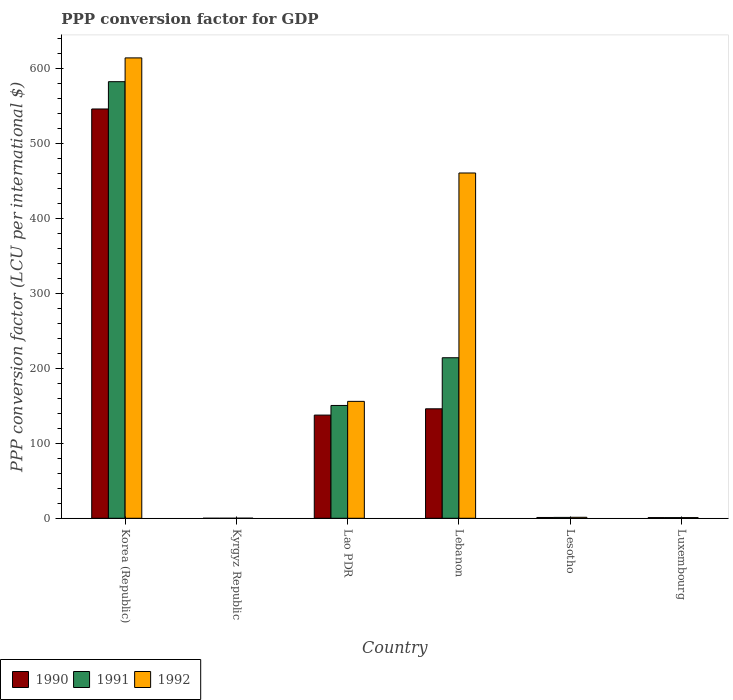How many different coloured bars are there?
Offer a terse response. 3. How many bars are there on the 4th tick from the left?
Ensure brevity in your answer.  3. In how many cases, is the number of bars for a given country not equal to the number of legend labels?
Ensure brevity in your answer.  0. What is the PPP conversion factor for GDP in 1990 in Lao PDR?
Provide a short and direct response. 137.64. Across all countries, what is the maximum PPP conversion factor for GDP in 1992?
Offer a very short reply. 614.12. Across all countries, what is the minimum PPP conversion factor for GDP in 1992?
Keep it short and to the point. 0.09. In which country was the PPP conversion factor for GDP in 1991 minimum?
Your response must be concise. Kyrgyz Republic. What is the total PPP conversion factor for GDP in 1991 in the graph?
Ensure brevity in your answer.  949.08. What is the difference between the PPP conversion factor for GDP in 1991 in Lao PDR and that in Lebanon?
Ensure brevity in your answer.  -63.66. What is the difference between the PPP conversion factor for GDP in 1990 in Lesotho and the PPP conversion factor for GDP in 1991 in Lao PDR?
Your response must be concise. -149.44. What is the average PPP conversion factor for GDP in 1990 per country?
Make the answer very short. 138.6. What is the difference between the PPP conversion factor for GDP of/in 1992 and PPP conversion factor for GDP of/in 1990 in Lesotho?
Provide a succinct answer. 0.25. What is the ratio of the PPP conversion factor for GDP in 1992 in Korea (Republic) to that in Lao PDR?
Give a very brief answer. 3.94. Is the difference between the PPP conversion factor for GDP in 1992 in Lao PDR and Lebanon greater than the difference between the PPP conversion factor for GDP in 1990 in Lao PDR and Lebanon?
Give a very brief answer. No. What is the difference between the highest and the second highest PPP conversion factor for GDP in 1991?
Make the answer very short. -63.66. What is the difference between the highest and the lowest PPP conversion factor for GDP in 1991?
Give a very brief answer. 582.38. Is the sum of the PPP conversion factor for GDP in 1990 in Lao PDR and Luxembourg greater than the maximum PPP conversion factor for GDP in 1992 across all countries?
Give a very brief answer. No. What does the 1st bar from the left in Lebanon represents?
Give a very brief answer. 1990. Is it the case that in every country, the sum of the PPP conversion factor for GDP in 1991 and PPP conversion factor for GDP in 1992 is greater than the PPP conversion factor for GDP in 1990?
Offer a terse response. Yes. Are all the bars in the graph horizontal?
Provide a short and direct response. No. How many countries are there in the graph?
Provide a short and direct response. 6. How are the legend labels stacked?
Keep it short and to the point. Horizontal. What is the title of the graph?
Offer a very short reply. PPP conversion factor for GDP. Does "1960" appear as one of the legend labels in the graph?
Your answer should be compact. No. What is the label or title of the X-axis?
Ensure brevity in your answer.  Country. What is the label or title of the Y-axis?
Provide a succinct answer. PPP conversion factor (LCU per international $). What is the PPP conversion factor (LCU per international $) in 1990 in Korea (Republic)?
Ensure brevity in your answer.  545.98. What is the PPP conversion factor (LCU per international $) in 1991 in Korea (Republic)?
Your answer should be compact. 582.39. What is the PPP conversion factor (LCU per international $) in 1992 in Korea (Republic)?
Make the answer very short. 614.12. What is the PPP conversion factor (LCU per international $) in 1990 in Kyrgyz Republic?
Ensure brevity in your answer.  0. What is the PPP conversion factor (LCU per international $) of 1991 in Kyrgyz Republic?
Make the answer very short. 0.01. What is the PPP conversion factor (LCU per international $) in 1992 in Kyrgyz Republic?
Offer a very short reply. 0.09. What is the PPP conversion factor (LCU per international $) of 1990 in Lao PDR?
Ensure brevity in your answer.  137.64. What is the PPP conversion factor (LCU per international $) of 1991 in Lao PDR?
Keep it short and to the point. 150.48. What is the PPP conversion factor (LCU per international $) in 1992 in Lao PDR?
Your answer should be very brief. 155.95. What is the PPP conversion factor (LCU per international $) of 1990 in Lebanon?
Your answer should be very brief. 146.02. What is the PPP conversion factor (LCU per international $) in 1991 in Lebanon?
Keep it short and to the point. 214.14. What is the PPP conversion factor (LCU per international $) of 1992 in Lebanon?
Keep it short and to the point. 460.59. What is the PPP conversion factor (LCU per international $) in 1990 in Lesotho?
Give a very brief answer. 1.05. What is the PPP conversion factor (LCU per international $) of 1991 in Lesotho?
Make the answer very short. 1.17. What is the PPP conversion factor (LCU per international $) in 1992 in Lesotho?
Offer a terse response. 1.3. What is the PPP conversion factor (LCU per international $) of 1990 in Luxembourg?
Ensure brevity in your answer.  0.9. What is the PPP conversion factor (LCU per international $) of 1991 in Luxembourg?
Provide a short and direct response. 0.89. What is the PPP conversion factor (LCU per international $) of 1992 in Luxembourg?
Your answer should be very brief. 0.9. Across all countries, what is the maximum PPP conversion factor (LCU per international $) of 1990?
Your answer should be very brief. 545.98. Across all countries, what is the maximum PPP conversion factor (LCU per international $) of 1991?
Provide a succinct answer. 582.39. Across all countries, what is the maximum PPP conversion factor (LCU per international $) of 1992?
Ensure brevity in your answer.  614.12. Across all countries, what is the minimum PPP conversion factor (LCU per international $) of 1990?
Keep it short and to the point. 0. Across all countries, what is the minimum PPP conversion factor (LCU per international $) of 1991?
Provide a short and direct response. 0.01. Across all countries, what is the minimum PPP conversion factor (LCU per international $) in 1992?
Ensure brevity in your answer.  0.09. What is the total PPP conversion factor (LCU per international $) of 1990 in the graph?
Your answer should be very brief. 831.59. What is the total PPP conversion factor (LCU per international $) in 1991 in the graph?
Provide a succinct answer. 949.08. What is the total PPP conversion factor (LCU per international $) of 1992 in the graph?
Offer a very short reply. 1232.95. What is the difference between the PPP conversion factor (LCU per international $) in 1990 in Korea (Republic) and that in Kyrgyz Republic?
Your response must be concise. 545.98. What is the difference between the PPP conversion factor (LCU per international $) in 1991 in Korea (Republic) and that in Kyrgyz Republic?
Offer a terse response. 582.38. What is the difference between the PPP conversion factor (LCU per international $) of 1992 in Korea (Republic) and that in Kyrgyz Republic?
Your answer should be very brief. 614.04. What is the difference between the PPP conversion factor (LCU per international $) in 1990 in Korea (Republic) and that in Lao PDR?
Make the answer very short. 408.34. What is the difference between the PPP conversion factor (LCU per international $) of 1991 in Korea (Republic) and that in Lao PDR?
Your response must be concise. 431.9. What is the difference between the PPP conversion factor (LCU per international $) in 1992 in Korea (Republic) and that in Lao PDR?
Provide a succinct answer. 458.18. What is the difference between the PPP conversion factor (LCU per international $) of 1990 in Korea (Republic) and that in Lebanon?
Your answer should be compact. 399.96. What is the difference between the PPP conversion factor (LCU per international $) of 1991 in Korea (Republic) and that in Lebanon?
Give a very brief answer. 368.25. What is the difference between the PPP conversion factor (LCU per international $) of 1992 in Korea (Republic) and that in Lebanon?
Your answer should be compact. 153.54. What is the difference between the PPP conversion factor (LCU per international $) in 1990 in Korea (Republic) and that in Lesotho?
Offer a terse response. 544.93. What is the difference between the PPP conversion factor (LCU per international $) of 1991 in Korea (Republic) and that in Lesotho?
Ensure brevity in your answer.  581.22. What is the difference between the PPP conversion factor (LCU per international $) of 1992 in Korea (Republic) and that in Lesotho?
Your answer should be compact. 612.83. What is the difference between the PPP conversion factor (LCU per international $) in 1990 in Korea (Republic) and that in Luxembourg?
Provide a short and direct response. 545.08. What is the difference between the PPP conversion factor (LCU per international $) in 1991 in Korea (Republic) and that in Luxembourg?
Offer a very short reply. 581.5. What is the difference between the PPP conversion factor (LCU per international $) of 1992 in Korea (Republic) and that in Luxembourg?
Keep it short and to the point. 613.22. What is the difference between the PPP conversion factor (LCU per international $) of 1990 in Kyrgyz Republic and that in Lao PDR?
Ensure brevity in your answer.  -137.63. What is the difference between the PPP conversion factor (LCU per international $) in 1991 in Kyrgyz Republic and that in Lao PDR?
Your answer should be compact. -150.47. What is the difference between the PPP conversion factor (LCU per international $) of 1992 in Kyrgyz Republic and that in Lao PDR?
Your response must be concise. -155.86. What is the difference between the PPP conversion factor (LCU per international $) of 1990 in Kyrgyz Republic and that in Lebanon?
Provide a short and direct response. -146.01. What is the difference between the PPP conversion factor (LCU per international $) of 1991 in Kyrgyz Republic and that in Lebanon?
Offer a terse response. -214.13. What is the difference between the PPP conversion factor (LCU per international $) of 1992 in Kyrgyz Republic and that in Lebanon?
Your answer should be very brief. -460.5. What is the difference between the PPP conversion factor (LCU per international $) of 1990 in Kyrgyz Republic and that in Lesotho?
Your answer should be compact. -1.04. What is the difference between the PPP conversion factor (LCU per international $) in 1991 in Kyrgyz Republic and that in Lesotho?
Provide a succinct answer. -1.16. What is the difference between the PPP conversion factor (LCU per international $) of 1992 in Kyrgyz Republic and that in Lesotho?
Keep it short and to the point. -1.21. What is the difference between the PPP conversion factor (LCU per international $) in 1990 in Kyrgyz Republic and that in Luxembourg?
Provide a short and direct response. -0.9. What is the difference between the PPP conversion factor (LCU per international $) of 1991 in Kyrgyz Republic and that in Luxembourg?
Offer a terse response. -0.88. What is the difference between the PPP conversion factor (LCU per international $) in 1992 in Kyrgyz Republic and that in Luxembourg?
Keep it short and to the point. -0.81. What is the difference between the PPP conversion factor (LCU per international $) of 1990 in Lao PDR and that in Lebanon?
Offer a terse response. -8.38. What is the difference between the PPP conversion factor (LCU per international $) of 1991 in Lao PDR and that in Lebanon?
Your answer should be very brief. -63.66. What is the difference between the PPP conversion factor (LCU per international $) of 1992 in Lao PDR and that in Lebanon?
Offer a terse response. -304.64. What is the difference between the PPP conversion factor (LCU per international $) in 1990 in Lao PDR and that in Lesotho?
Your answer should be compact. 136.59. What is the difference between the PPP conversion factor (LCU per international $) in 1991 in Lao PDR and that in Lesotho?
Provide a short and direct response. 149.32. What is the difference between the PPP conversion factor (LCU per international $) of 1992 in Lao PDR and that in Lesotho?
Keep it short and to the point. 154.65. What is the difference between the PPP conversion factor (LCU per international $) in 1990 in Lao PDR and that in Luxembourg?
Your answer should be very brief. 136.74. What is the difference between the PPP conversion factor (LCU per international $) in 1991 in Lao PDR and that in Luxembourg?
Provide a short and direct response. 149.6. What is the difference between the PPP conversion factor (LCU per international $) of 1992 in Lao PDR and that in Luxembourg?
Provide a short and direct response. 155.05. What is the difference between the PPP conversion factor (LCU per international $) in 1990 in Lebanon and that in Lesotho?
Keep it short and to the point. 144.97. What is the difference between the PPP conversion factor (LCU per international $) of 1991 in Lebanon and that in Lesotho?
Offer a terse response. 212.98. What is the difference between the PPP conversion factor (LCU per international $) of 1992 in Lebanon and that in Lesotho?
Give a very brief answer. 459.29. What is the difference between the PPP conversion factor (LCU per international $) in 1990 in Lebanon and that in Luxembourg?
Ensure brevity in your answer.  145.11. What is the difference between the PPP conversion factor (LCU per international $) of 1991 in Lebanon and that in Luxembourg?
Your answer should be very brief. 213.25. What is the difference between the PPP conversion factor (LCU per international $) of 1992 in Lebanon and that in Luxembourg?
Your response must be concise. 459.69. What is the difference between the PPP conversion factor (LCU per international $) in 1990 in Lesotho and that in Luxembourg?
Ensure brevity in your answer.  0.15. What is the difference between the PPP conversion factor (LCU per international $) of 1991 in Lesotho and that in Luxembourg?
Provide a succinct answer. 0.28. What is the difference between the PPP conversion factor (LCU per international $) in 1992 in Lesotho and that in Luxembourg?
Offer a terse response. 0.4. What is the difference between the PPP conversion factor (LCU per international $) of 1990 in Korea (Republic) and the PPP conversion factor (LCU per international $) of 1991 in Kyrgyz Republic?
Offer a very short reply. 545.97. What is the difference between the PPP conversion factor (LCU per international $) in 1990 in Korea (Republic) and the PPP conversion factor (LCU per international $) in 1992 in Kyrgyz Republic?
Make the answer very short. 545.89. What is the difference between the PPP conversion factor (LCU per international $) of 1991 in Korea (Republic) and the PPP conversion factor (LCU per international $) of 1992 in Kyrgyz Republic?
Your response must be concise. 582.3. What is the difference between the PPP conversion factor (LCU per international $) of 1990 in Korea (Republic) and the PPP conversion factor (LCU per international $) of 1991 in Lao PDR?
Your response must be concise. 395.5. What is the difference between the PPP conversion factor (LCU per international $) in 1990 in Korea (Republic) and the PPP conversion factor (LCU per international $) in 1992 in Lao PDR?
Provide a succinct answer. 390.03. What is the difference between the PPP conversion factor (LCU per international $) in 1991 in Korea (Republic) and the PPP conversion factor (LCU per international $) in 1992 in Lao PDR?
Ensure brevity in your answer.  426.44. What is the difference between the PPP conversion factor (LCU per international $) in 1990 in Korea (Republic) and the PPP conversion factor (LCU per international $) in 1991 in Lebanon?
Provide a short and direct response. 331.84. What is the difference between the PPP conversion factor (LCU per international $) of 1990 in Korea (Republic) and the PPP conversion factor (LCU per international $) of 1992 in Lebanon?
Provide a succinct answer. 85.39. What is the difference between the PPP conversion factor (LCU per international $) in 1991 in Korea (Republic) and the PPP conversion factor (LCU per international $) in 1992 in Lebanon?
Ensure brevity in your answer.  121.8. What is the difference between the PPP conversion factor (LCU per international $) in 1990 in Korea (Republic) and the PPP conversion factor (LCU per international $) in 1991 in Lesotho?
Your response must be concise. 544.81. What is the difference between the PPP conversion factor (LCU per international $) of 1990 in Korea (Republic) and the PPP conversion factor (LCU per international $) of 1992 in Lesotho?
Your response must be concise. 544.68. What is the difference between the PPP conversion factor (LCU per international $) in 1991 in Korea (Republic) and the PPP conversion factor (LCU per international $) in 1992 in Lesotho?
Provide a short and direct response. 581.09. What is the difference between the PPP conversion factor (LCU per international $) of 1990 in Korea (Republic) and the PPP conversion factor (LCU per international $) of 1991 in Luxembourg?
Your answer should be compact. 545.09. What is the difference between the PPP conversion factor (LCU per international $) of 1990 in Korea (Republic) and the PPP conversion factor (LCU per international $) of 1992 in Luxembourg?
Provide a succinct answer. 545.08. What is the difference between the PPP conversion factor (LCU per international $) of 1991 in Korea (Republic) and the PPP conversion factor (LCU per international $) of 1992 in Luxembourg?
Give a very brief answer. 581.48. What is the difference between the PPP conversion factor (LCU per international $) of 1990 in Kyrgyz Republic and the PPP conversion factor (LCU per international $) of 1991 in Lao PDR?
Offer a terse response. -150.48. What is the difference between the PPP conversion factor (LCU per international $) of 1990 in Kyrgyz Republic and the PPP conversion factor (LCU per international $) of 1992 in Lao PDR?
Provide a short and direct response. -155.94. What is the difference between the PPP conversion factor (LCU per international $) in 1991 in Kyrgyz Republic and the PPP conversion factor (LCU per international $) in 1992 in Lao PDR?
Provide a succinct answer. -155.94. What is the difference between the PPP conversion factor (LCU per international $) in 1990 in Kyrgyz Republic and the PPP conversion factor (LCU per international $) in 1991 in Lebanon?
Provide a short and direct response. -214.14. What is the difference between the PPP conversion factor (LCU per international $) in 1990 in Kyrgyz Republic and the PPP conversion factor (LCU per international $) in 1992 in Lebanon?
Your answer should be compact. -460.58. What is the difference between the PPP conversion factor (LCU per international $) in 1991 in Kyrgyz Republic and the PPP conversion factor (LCU per international $) in 1992 in Lebanon?
Make the answer very short. -460.58. What is the difference between the PPP conversion factor (LCU per international $) in 1990 in Kyrgyz Republic and the PPP conversion factor (LCU per international $) in 1991 in Lesotho?
Give a very brief answer. -1.16. What is the difference between the PPP conversion factor (LCU per international $) in 1990 in Kyrgyz Republic and the PPP conversion factor (LCU per international $) in 1992 in Lesotho?
Your response must be concise. -1.29. What is the difference between the PPP conversion factor (LCU per international $) in 1991 in Kyrgyz Republic and the PPP conversion factor (LCU per international $) in 1992 in Lesotho?
Keep it short and to the point. -1.29. What is the difference between the PPP conversion factor (LCU per international $) in 1990 in Kyrgyz Republic and the PPP conversion factor (LCU per international $) in 1991 in Luxembourg?
Your answer should be compact. -0.88. What is the difference between the PPP conversion factor (LCU per international $) of 1990 in Kyrgyz Republic and the PPP conversion factor (LCU per international $) of 1992 in Luxembourg?
Offer a very short reply. -0.9. What is the difference between the PPP conversion factor (LCU per international $) of 1991 in Kyrgyz Republic and the PPP conversion factor (LCU per international $) of 1992 in Luxembourg?
Make the answer very short. -0.89. What is the difference between the PPP conversion factor (LCU per international $) of 1990 in Lao PDR and the PPP conversion factor (LCU per international $) of 1991 in Lebanon?
Keep it short and to the point. -76.5. What is the difference between the PPP conversion factor (LCU per international $) in 1990 in Lao PDR and the PPP conversion factor (LCU per international $) in 1992 in Lebanon?
Offer a very short reply. -322.95. What is the difference between the PPP conversion factor (LCU per international $) of 1991 in Lao PDR and the PPP conversion factor (LCU per international $) of 1992 in Lebanon?
Your response must be concise. -310.1. What is the difference between the PPP conversion factor (LCU per international $) in 1990 in Lao PDR and the PPP conversion factor (LCU per international $) in 1991 in Lesotho?
Your response must be concise. 136.47. What is the difference between the PPP conversion factor (LCU per international $) in 1990 in Lao PDR and the PPP conversion factor (LCU per international $) in 1992 in Lesotho?
Offer a terse response. 136.34. What is the difference between the PPP conversion factor (LCU per international $) of 1991 in Lao PDR and the PPP conversion factor (LCU per international $) of 1992 in Lesotho?
Provide a short and direct response. 149.19. What is the difference between the PPP conversion factor (LCU per international $) of 1990 in Lao PDR and the PPP conversion factor (LCU per international $) of 1991 in Luxembourg?
Keep it short and to the point. 136.75. What is the difference between the PPP conversion factor (LCU per international $) in 1990 in Lao PDR and the PPP conversion factor (LCU per international $) in 1992 in Luxembourg?
Provide a short and direct response. 136.74. What is the difference between the PPP conversion factor (LCU per international $) of 1991 in Lao PDR and the PPP conversion factor (LCU per international $) of 1992 in Luxembourg?
Make the answer very short. 149.58. What is the difference between the PPP conversion factor (LCU per international $) in 1990 in Lebanon and the PPP conversion factor (LCU per international $) in 1991 in Lesotho?
Ensure brevity in your answer.  144.85. What is the difference between the PPP conversion factor (LCU per international $) in 1990 in Lebanon and the PPP conversion factor (LCU per international $) in 1992 in Lesotho?
Offer a very short reply. 144.72. What is the difference between the PPP conversion factor (LCU per international $) in 1991 in Lebanon and the PPP conversion factor (LCU per international $) in 1992 in Lesotho?
Ensure brevity in your answer.  212.84. What is the difference between the PPP conversion factor (LCU per international $) in 1990 in Lebanon and the PPP conversion factor (LCU per international $) in 1991 in Luxembourg?
Your answer should be compact. 145.13. What is the difference between the PPP conversion factor (LCU per international $) of 1990 in Lebanon and the PPP conversion factor (LCU per international $) of 1992 in Luxembourg?
Your answer should be compact. 145.11. What is the difference between the PPP conversion factor (LCU per international $) of 1991 in Lebanon and the PPP conversion factor (LCU per international $) of 1992 in Luxembourg?
Provide a succinct answer. 213.24. What is the difference between the PPP conversion factor (LCU per international $) in 1990 in Lesotho and the PPP conversion factor (LCU per international $) in 1991 in Luxembourg?
Your answer should be very brief. 0.16. What is the difference between the PPP conversion factor (LCU per international $) in 1990 in Lesotho and the PPP conversion factor (LCU per international $) in 1992 in Luxembourg?
Give a very brief answer. 0.15. What is the difference between the PPP conversion factor (LCU per international $) in 1991 in Lesotho and the PPP conversion factor (LCU per international $) in 1992 in Luxembourg?
Make the answer very short. 0.26. What is the average PPP conversion factor (LCU per international $) of 1990 per country?
Give a very brief answer. 138.6. What is the average PPP conversion factor (LCU per international $) of 1991 per country?
Your response must be concise. 158.18. What is the average PPP conversion factor (LCU per international $) in 1992 per country?
Your answer should be very brief. 205.49. What is the difference between the PPP conversion factor (LCU per international $) in 1990 and PPP conversion factor (LCU per international $) in 1991 in Korea (Republic)?
Give a very brief answer. -36.41. What is the difference between the PPP conversion factor (LCU per international $) in 1990 and PPP conversion factor (LCU per international $) in 1992 in Korea (Republic)?
Give a very brief answer. -68.14. What is the difference between the PPP conversion factor (LCU per international $) in 1991 and PPP conversion factor (LCU per international $) in 1992 in Korea (Republic)?
Provide a short and direct response. -31.74. What is the difference between the PPP conversion factor (LCU per international $) in 1990 and PPP conversion factor (LCU per international $) in 1991 in Kyrgyz Republic?
Provide a short and direct response. -0.01. What is the difference between the PPP conversion factor (LCU per international $) in 1990 and PPP conversion factor (LCU per international $) in 1992 in Kyrgyz Republic?
Your answer should be compact. -0.09. What is the difference between the PPP conversion factor (LCU per international $) in 1991 and PPP conversion factor (LCU per international $) in 1992 in Kyrgyz Republic?
Give a very brief answer. -0.08. What is the difference between the PPP conversion factor (LCU per international $) of 1990 and PPP conversion factor (LCU per international $) of 1991 in Lao PDR?
Provide a short and direct response. -12.85. What is the difference between the PPP conversion factor (LCU per international $) of 1990 and PPP conversion factor (LCU per international $) of 1992 in Lao PDR?
Your response must be concise. -18.31. What is the difference between the PPP conversion factor (LCU per international $) in 1991 and PPP conversion factor (LCU per international $) in 1992 in Lao PDR?
Ensure brevity in your answer.  -5.46. What is the difference between the PPP conversion factor (LCU per international $) in 1990 and PPP conversion factor (LCU per international $) in 1991 in Lebanon?
Provide a short and direct response. -68.13. What is the difference between the PPP conversion factor (LCU per international $) in 1990 and PPP conversion factor (LCU per international $) in 1992 in Lebanon?
Provide a short and direct response. -314.57. What is the difference between the PPP conversion factor (LCU per international $) in 1991 and PPP conversion factor (LCU per international $) in 1992 in Lebanon?
Provide a short and direct response. -246.45. What is the difference between the PPP conversion factor (LCU per international $) in 1990 and PPP conversion factor (LCU per international $) in 1991 in Lesotho?
Your answer should be compact. -0.12. What is the difference between the PPP conversion factor (LCU per international $) of 1990 and PPP conversion factor (LCU per international $) of 1992 in Lesotho?
Make the answer very short. -0.25. What is the difference between the PPP conversion factor (LCU per international $) of 1991 and PPP conversion factor (LCU per international $) of 1992 in Lesotho?
Give a very brief answer. -0.13. What is the difference between the PPP conversion factor (LCU per international $) in 1990 and PPP conversion factor (LCU per international $) in 1991 in Luxembourg?
Your response must be concise. 0.01. What is the difference between the PPP conversion factor (LCU per international $) of 1990 and PPP conversion factor (LCU per international $) of 1992 in Luxembourg?
Your answer should be very brief. 0. What is the difference between the PPP conversion factor (LCU per international $) in 1991 and PPP conversion factor (LCU per international $) in 1992 in Luxembourg?
Your response must be concise. -0.01. What is the ratio of the PPP conversion factor (LCU per international $) in 1990 in Korea (Republic) to that in Kyrgyz Republic?
Your answer should be compact. 1.26e+05. What is the ratio of the PPP conversion factor (LCU per international $) in 1991 in Korea (Republic) to that in Kyrgyz Republic?
Make the answer very short. 5.91e+04. What is the ratio of the PPP conversion factor (LCU per international $) in 1992 in Korea (Republic) to that in Kyrgyz Republic?
Give a very brief answer. 6851.33. What is the ratio of the PPP conversion factor (LCU per international $) of 1990 in Korea (Republic) to that in Lao PDR?
Provide a succinct answer. 3.97. What is the ratio of the PPP conversion factor (LCU per international $) of 1991 in Korea (Republic) to that in Lao PDR?
Your answer should be compact. 3.87. What is the ratio of the PPP conversion factor (LCU per international $) of 1992 in Korea (Republic) to that in Lao PDR?
Offer a terse response. 3.94. What is the ratio of the PPP conversion factor (LCU per international $) in 1990 in Korea (Republic) to that in Lebanon?
Offer a very short reply. 3.74. What is the ratio of the PPP conversion factor (LCU per international $) of 1991 in Korea (Republic) to that in Lebanon?
Ensure brevity in your answer.  2.72. What is the ratio of the PPP conversion factor (LCU per international $) in 1990 in Korea (Republic) to that in Lesotho?
Ensure brevity in your answer.  520.35. What is the ratio of the PPP conversion factor (LCU per international $) in 1991 in Korea (Republic) to that in Lesotho?
Ensure brevity in your answer.  499.49. What is the ratio of the PPP conversion factor (LCU per international $) of 1992 in Korea (Republic) to that in Lesotho?
Your response must be concise. 472.65. What is the ratio of the PPP conversion factor (LCU per international $) of 1990 in Korea (Republic) to that in Luxembourg?
Offer a very short reply. 605.03. What is the ratio of the PPP conversion factor (LCU per international $) in 1991 in Korea (Republic) to that in Luxembourg?
Your answer should be very brief. 654.92. What is the ratio of the PPP conversion factor (LCU per international $) in 1992 in Korea (Republic) to that in Luxembourg?
Provide a succinct answer. 680.96. What is the ratio of the PPP conversion factor (LCU per international $) in 1991 in Kyrgyz Republic to that in Lao PDR?
Ensure brevity in your answer.  0. What is the ratio of the PPP conversion factor (LCU per international $) of 1992 in Kyrgyz Republic to that in Lao PDR?
Provide a succinct answer. 0. What is the ratio of the PPP conversion factor (LCU per international $) of 1990 in Kyrgyz Republic to that in Lebanon?
Offer a very short reply. 0. What is the ratio of the PPP conversion factor (LCU per international $) of 1992 in Kyrgyz Republic to that in Lebanon?
Provide a succinct answer. 0. What is the ratio of the PPP conversion factor (LCU per international $) in 1990 in Kyrgyz Republic to that in Lesotho?
Your response must be concise. 0. What is the ratio of the PPP conversion factor (LCU per international $) in 1991 in Kyrgyz Republic to that in Lesotho?
Offer a very short reply. 0.01. What is the ratio of the PPP conversion factor (LCU per international $) of 1992 in Kyrgyz Republic to that in Lesotho?
Provide a short and direct response. 0.07. What is the ratio of the PPP conversion factor (LCU per international $) in 1990 in Kyrgyz Republic to that in Luxembourg?
Provide a succinct answer. 0. What is the ratio of the PPP conversion factor (LCU per international $) of 1991 in Kyrgyz Republic to that in Luxembourg?
Keep it short and to the point. 0.01. What is the ratio of the PPP conversion factor (LCU per international $) in 1992 in Kyrgyz Republic to that in Luxembourg?
Your response must be concise. 0.1. What is the ratio of the PPP conversion factor (LCU per international $) in 1990 in Lao PDR to that in Lebanon?
Make the answer very short. 0.94. What is the ratio of the PPP conversion factor (LCU per international $) in 1991 in Lao PDR to that in Lebanon?
Provide a short and direct response. 0.7. What is the ratio of the PPP conversion factor (LCU per international $) in 1992 in Lao PDR to that in Lebanon?
Offer a very short reply. 0.34. What is the ratio of the PPP conversion factor (LCU per international $) in 1990 in Lao PDR to that in Lesotho?
Provide a succinct answer. 131.18. What is the ratio of the PPP conversion factor (LCU per international $) in 1991 in Lao PDR to that in Lesotho?
Provide a succinct answer. 129.07. What is the ratio of the PPP conversion factor (LCU per international $) of 1992 in Lao PDR to that in Lesotho?
Ensure brevity in your answer.  120.02. What is the ratio of the PPP conversion factor (LCU per international $) of 1990 in Lao PDR to that in Luxembourg?
Make the answer very short. 152.52. What is the ratio of the PPP conversion factor (LCU per international $) in 1991 in Lao PDR to that in Luxembourg?
Ensure brevity in your answer.  169.23. What is the ratio of the PPP conversion factor (LCU per international $) in 1992 in Lao PDR to that in Luxembourg?
Your answer should be very brief. 172.92. What is the ratio of the PPP conversion factor (LCU per international $) in 1990 in Lebanon to that in Lesotho?
Offer a terse response. 139.16. What is the ratio of the PPP conversion factor (LCU per international $) in 1991 in Lebanon to that in Lesotho?
Offer a terse response. 183.66. What is the ratio of the PPP conversion factor (LCU per international $) of 1992 in Lebanon to that in Lesotho?
Your answer should be compact. 354.48. What is the ratio of the PPP conversion factor (LCU per international $) of 1990 in Lebanon to that in Luxembourg?
Offer a very short reply. 161.81. What is the ratio of the PPP conversion factor (LCU per international $) of 1991 in Lebanon to that in Luxembourg?
Give a very brief answer. 240.81. What is the ratio of the PPP conversion factor (LCU per international $) in 1992 in Lebanon to that in Luxembourg?
Offer a terse response. 510.71. What is the ratio of the PPP conversion factor (LCU per international $) of 1990 in Lesotho to that in Luxembourg?
Your answer should be compact. 1.16. What is the ratio of the PPP conversion factor (LCU per international $) of 1991 in Lesotho to that in Luxembourg?
Keep it short and to the point. 1.31. What is the ratio of the PPP conversion factor (LCU per international $) of 1992 in Lesotho to that in Luxembourg?
Make the answer very short. 1.44. What is the difference between the highest and the second highest PPP conversion factor (LCU per international $) of 1990?
Make the answer very short. 399.96. What is the difference between the highest and the second highest PPP conversion factor (LCU per international $) of 1991?
Your answer should be compact. 368.25. What is the difference between the highest and the second highest PPP conversion factor (LCU per international $) of 1992?
Offer a terse response. 153.54. What is the difference between the highest and the lowest PPP conversion factor (LCU per international $) in 1990?
Keep it short and to the point. 545.98. What is the difference between the highest and the lowest PPP conversion factor (LCU per international $) of 1991?
Offer a very short reply. 582.38. What is the difference between the highest and the lowest PPP conversion factor (LCU per international $) of 1992?
Make the answer very short. 614.04. 